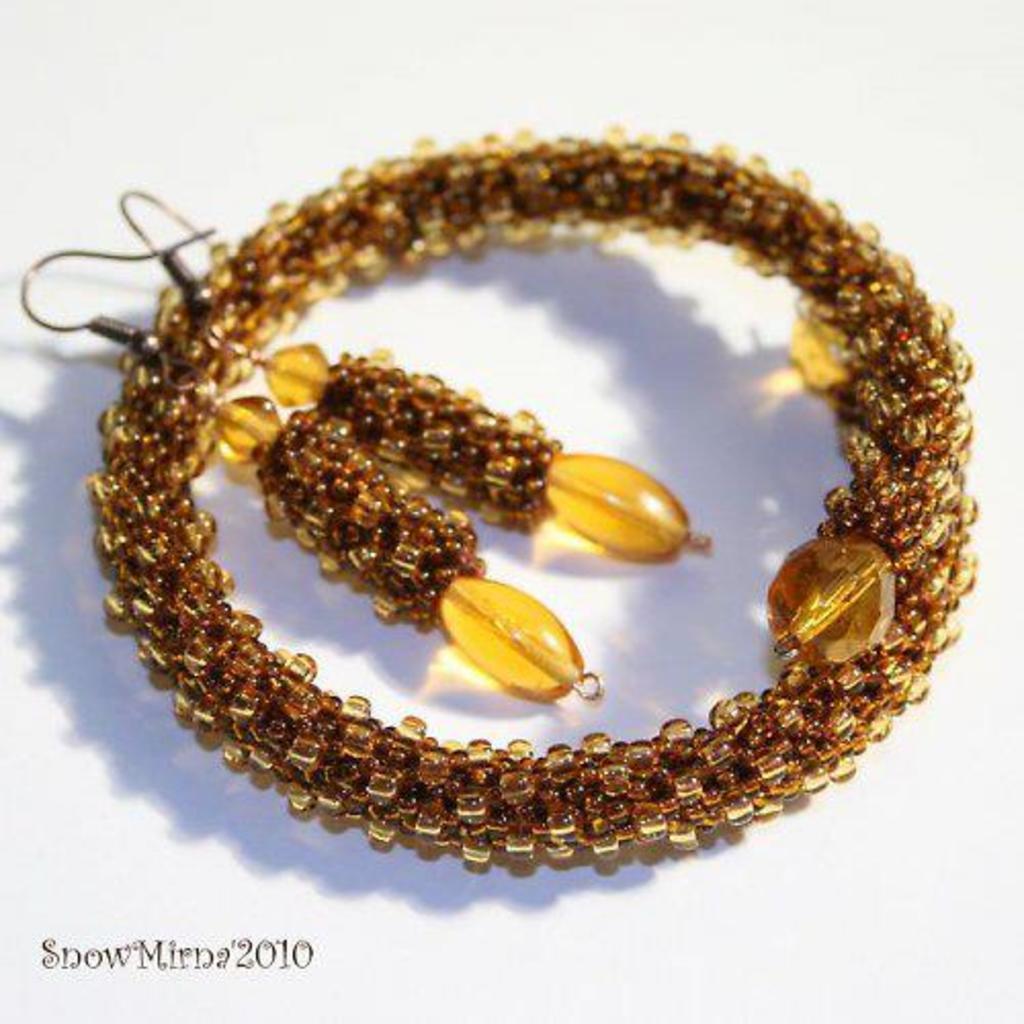In one or two sentences, can you explain what this image depicts? In this image I can see earrings and bracelet which is in brown color. Background is white in color. 